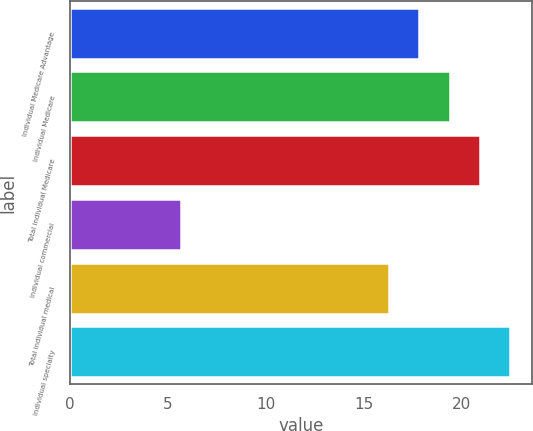Convert chart. <chart><loc_0><loc_0><loc_500><loc_500><bar_chart><fcel>Individual Medicare Advantage<fcel>Individual Medicare<fcel>Total individual Medicare<fcel>Individual commercial<fcel>Total individual medical<fcel>Individual specialty<nl><fcel>17.85<fcel>19.4<fcel>20.95<fcel>5.7<fcel>16.3<fcel>22.5<nl></chart> 